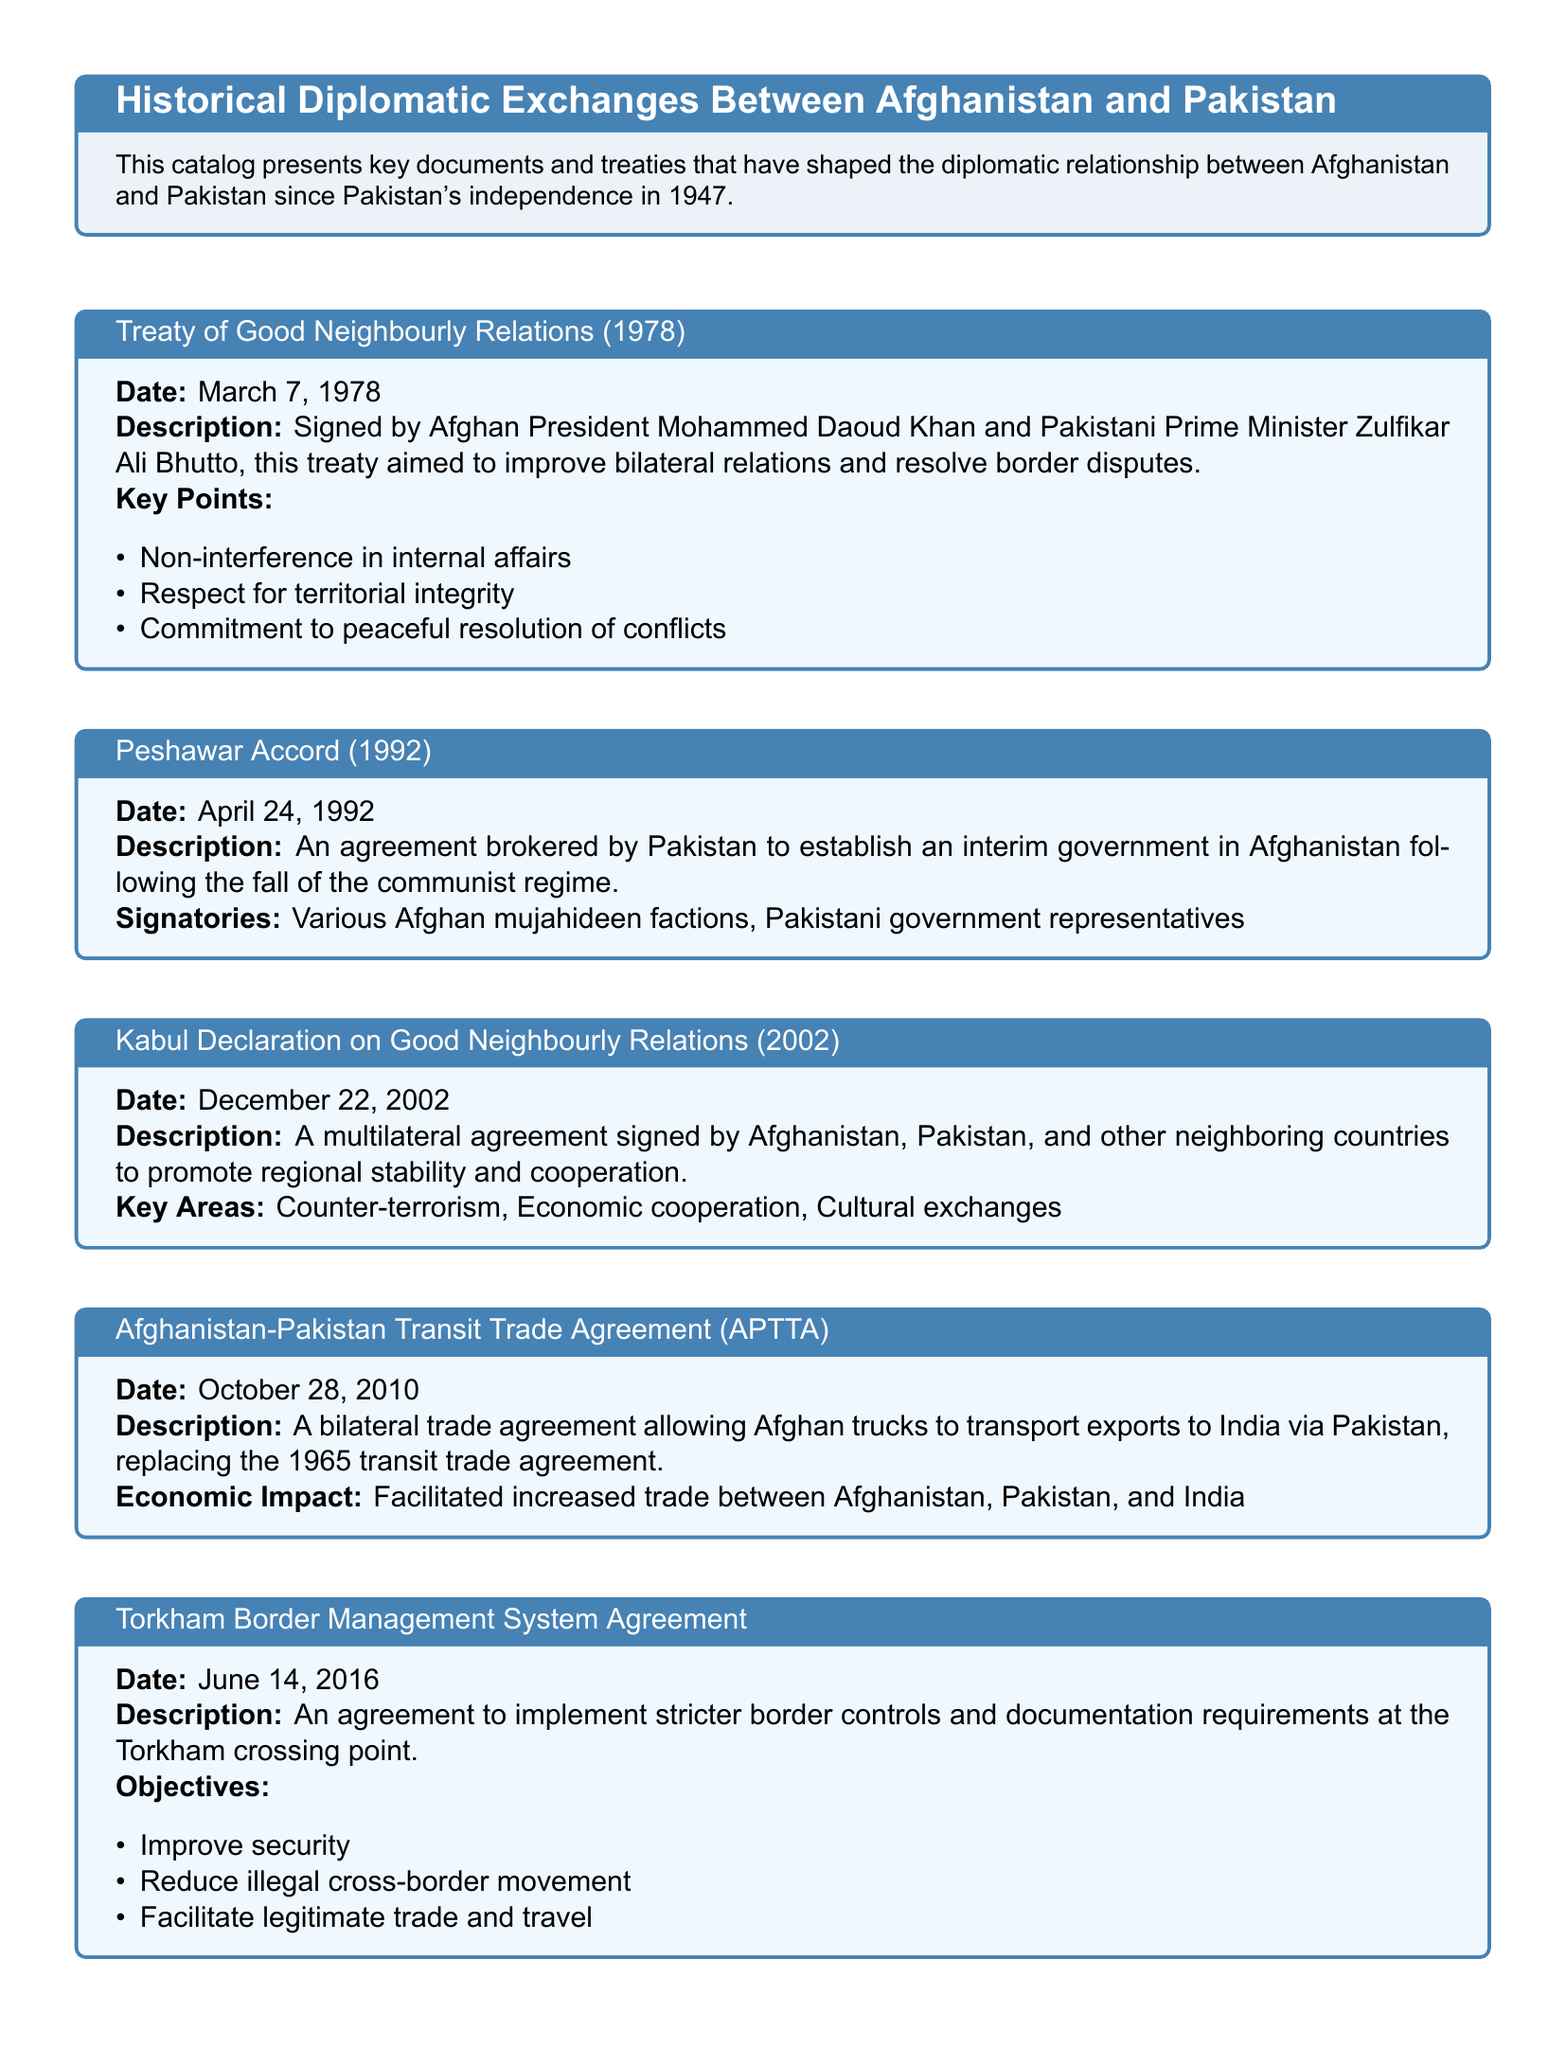What is the date of the Treaty of Good Neighbourly Relations? The date is specified in the document as March 7, 1978.
Answer: March 7, 1978 Who signed the Peshawar Accord? The document indicates that various Afghan mujahideen factions and Pakistani government representatives signed the accord.
Answer: Various Afghan mujahideen factions, Pakistani government representatives What was the aim of the Kabul Declaration on Good Neighbourly Relations? The document describes it as a multilateral agreement to promote regional stability and cooperation.
Answer: Promote regional stability and cooperation What year was the Afghanistan-Pakistan Transit Trade Agreement signed? The agreement is cited in the document as having been signed on October 28, 2010.
Answer: October 28, 2010 What are the objectives of the Torkham Border Management System Agreement? The document outlines three specific objectives: improve security, reduce illegal cross-border movement, and facilitate legitimate trade and travel.
Answer: Improve security, reduce illegal cross-border movement, facilitate legitimate trade and travel Which two countries signed the Treaty of Good Neighbourly Relations? The document lists the signatories as Afghan President Mohammed Daoud Khan and Pakistani Prime Minister Zulfikar Ali Bhutto.
Answer: Afghan President Mohammed Daoud Khan and Pakistani Prime Minister Zulfikar Ali Bhutto What economic impact did the Afghanistan-Pakistan Transit Trade Agreement facilitate? The document states that it facilitated increased trade between Afghanistan, Pakistan, and India.
Answer: Increased trade between Afghanistan, Pakistan, and India What key point does the Treaty of Good Neighbourly Relations emphasize? The document lists non-interference in internal affairs as a key point of the treaty.
Answer: Non-interference in internal affairs What was the date of the Kabul Declaration? The date mentioned in the document for the Kabul Declaration is December 22, 2002.
Answer: December 22, 2002 